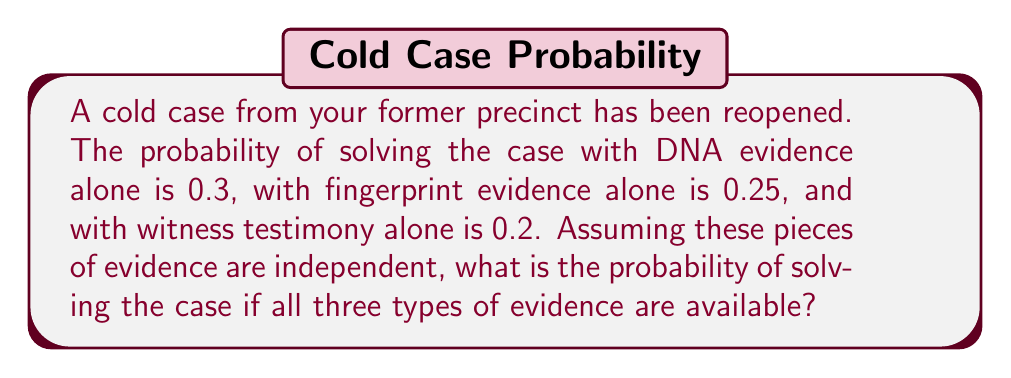Provide a solution to this math problem. Let's approach this step-by-step:

1) First, we need to understand that we're looking for the probability of solving the case with at least one type of evidence. This is equivalent to 1 minus the probability of not solving the case with any evidence.

2) Let's define our events:
   A: Solve with DNA evidence
   B: Solve with fingerprint evidence
   C: Solve with witness testimony

3) We're given:
   P(A) = 0.3
   P(B) = 0.25
   P(C) = 0.2

4) The probability of not solving with DNA is:
   P(not A) = 1 - P(A) = 1 - 0.3 = 0.7

5) Similarly:
   P(not B) = 1 - 0.25 = 0.75
   P(not C) = 1 - 0.2 = 0.8

6) The probability of not solving with any evidence is the product of these probabilities (since they're independent):
   P(not A and not B and not C) = P(not A) × P(not B) × P(not C)
                                 = 0.7 × 0.75 × 0.8
                                 = 0.42

7) Therefore, the probability of solving the case with at least one type of evidence is:
   P(solving) = 1 - P(not solving)
              = 1 - 0.42
              = 0.58

So, the probability of solving the case is 0.58 or 58%.
Answer: 0.58 